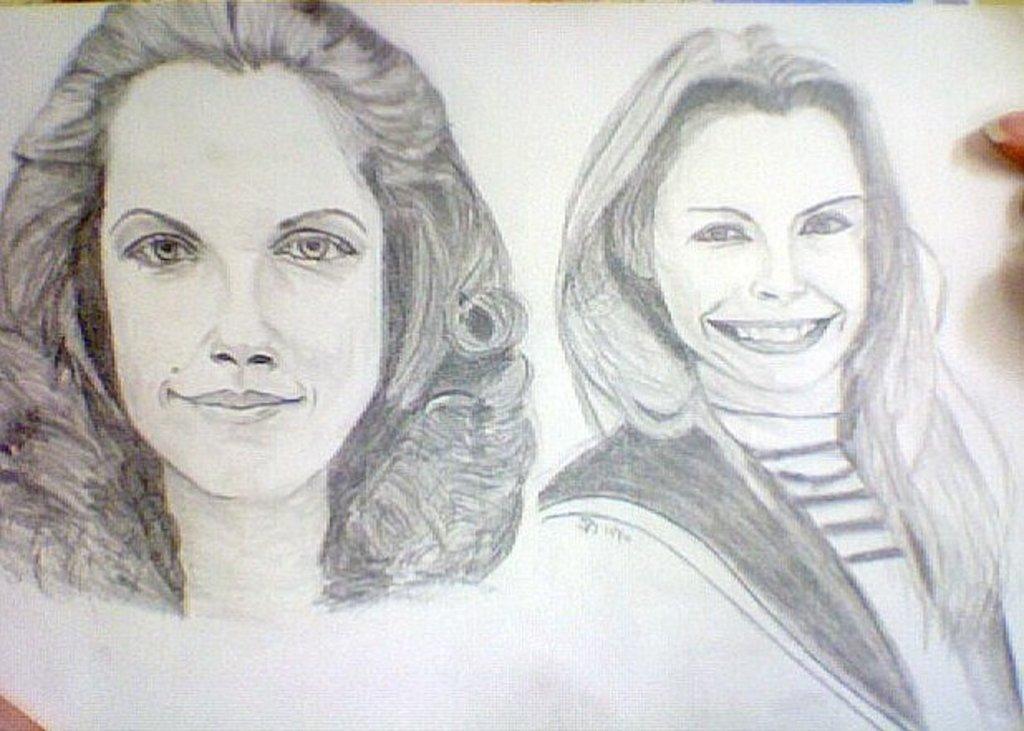Describe this image in one or two sentences. In this image we can see a drawing of two women on a paper. 